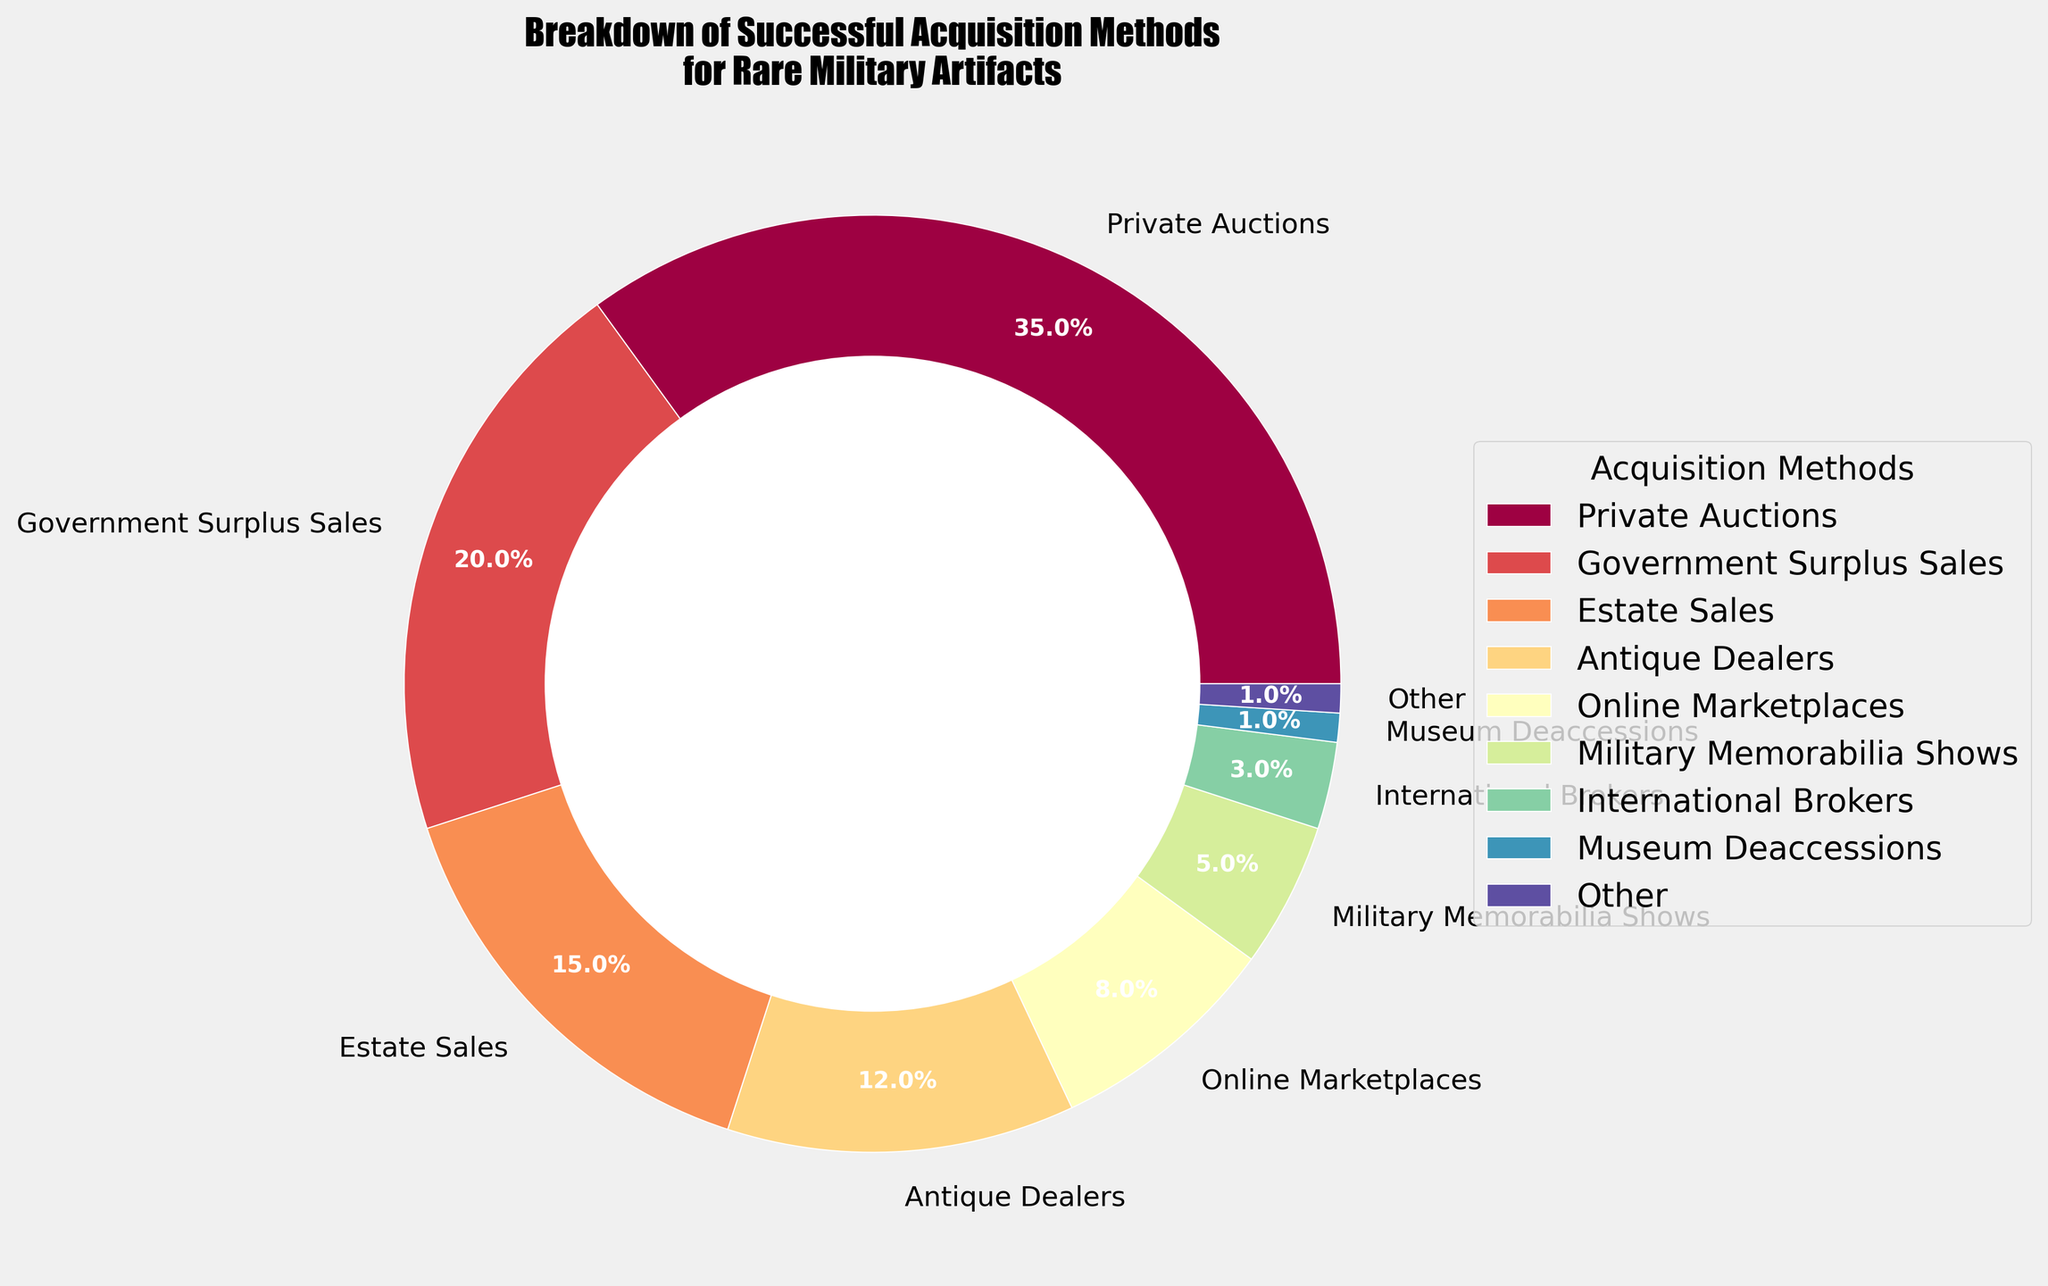What is the largest segment in the pie chart? The largest segment is labeled "Private Auctions" with the highest percentage.
Answer: Private Auctions What is the combined percentage of Government Surplus Sales and Estate Sales? Government Surplus Sales is 20% and Estate Sales is 15%. Adding them together gives 20 + 15 = 35%.
Answer: 35% Which segments are included under "other", and what is their total percentage? Segments under 1% are included under "other". These are Museum Deaccessions (1%), Salvage Operations (0.5%), Diplomatic Channels (0.3%), and Intelligence Networks (0.2%). Adding them gives 1 + 0.5 + 0.3 + 0.2 = 2%.
Answer: Museum Deaccessions, Salvage Operations, Diplomatic Channels, Intelligence Networks; 2% Which method has a greater share, Antique Dealers or Online Marketplaces? Antique Dealers have 12%, while Online Marketplaces have 8%. So, Antique Dealers have a greater share.
Answer: Antique Dealers What is the percentage difference between Military Memorabilia Shows and International Brokers? Military Memorabilia Shows have 5% and International Brokers have 3%. Subtracting them gives 5 - 3 = 2%.
Answer: 2% How many methods have a percentage greater than or equal to 10%? The methods with percentages greater than or equal to 10% are Private Auctions (35%), Government Surplus Sales (20%), and Estate Sales (15%). So, there are 3 such methods.
Answer: 3 What is the visual color gradient used in the pie chart? The pie chart uses a custom palette with the Spectral color gradient, having a smooth transition from blue through green to red and purple tones.
Answer: Spectral gradient What is the total percentage of the top three segments combined? The top three segments are Private Auctions (35%), Government Surplus Sales (20%), and Estate Sales (15%). Summing them up gives 35 + 20 + 15 = 70%.
Answer: 70% Which acquisition method is displayed with the smallest segment, excluding those under "other"? Military Memorabilia Shows have the smallest segment with 5%, excluding those under "other".
Answer: Military Memorabilia Shows What is the percentage of methods labeled under the "center left" legend? The legend "center left" labels represent all visible methods in the chart. Summing these percentages yields the total visualized.
Answer: 100% 